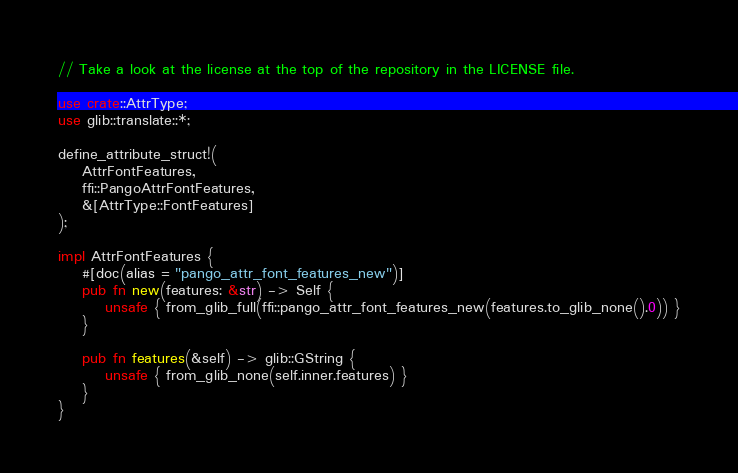<code> <loc_0><loc_0><loc_500><loc_500><_Rust_>// Take a look at the license at the top of the repository in the LICENSE file.

use crate::AttrType;
use glib::translate::*;

define_attribute_struct!(
    AttrFontFeatures,
    ffi::PangoAttrFontFeatures,
    &[AttrType::FontFeatures]
);

impl AttrFontFeatures {
    #[doc(alias = "pango_attr_font_features_new")]
    pub fn new(features: &str) -> Self {
        unsafe { from_glib_full(ffi::pango_attr_font_features_new(features.to_glib_none().0)) }
    }

    pub fn features(&self) -> glib::GString {
        unsafe { from_glib_none(self.inner.features) }
    }
}
</code> 